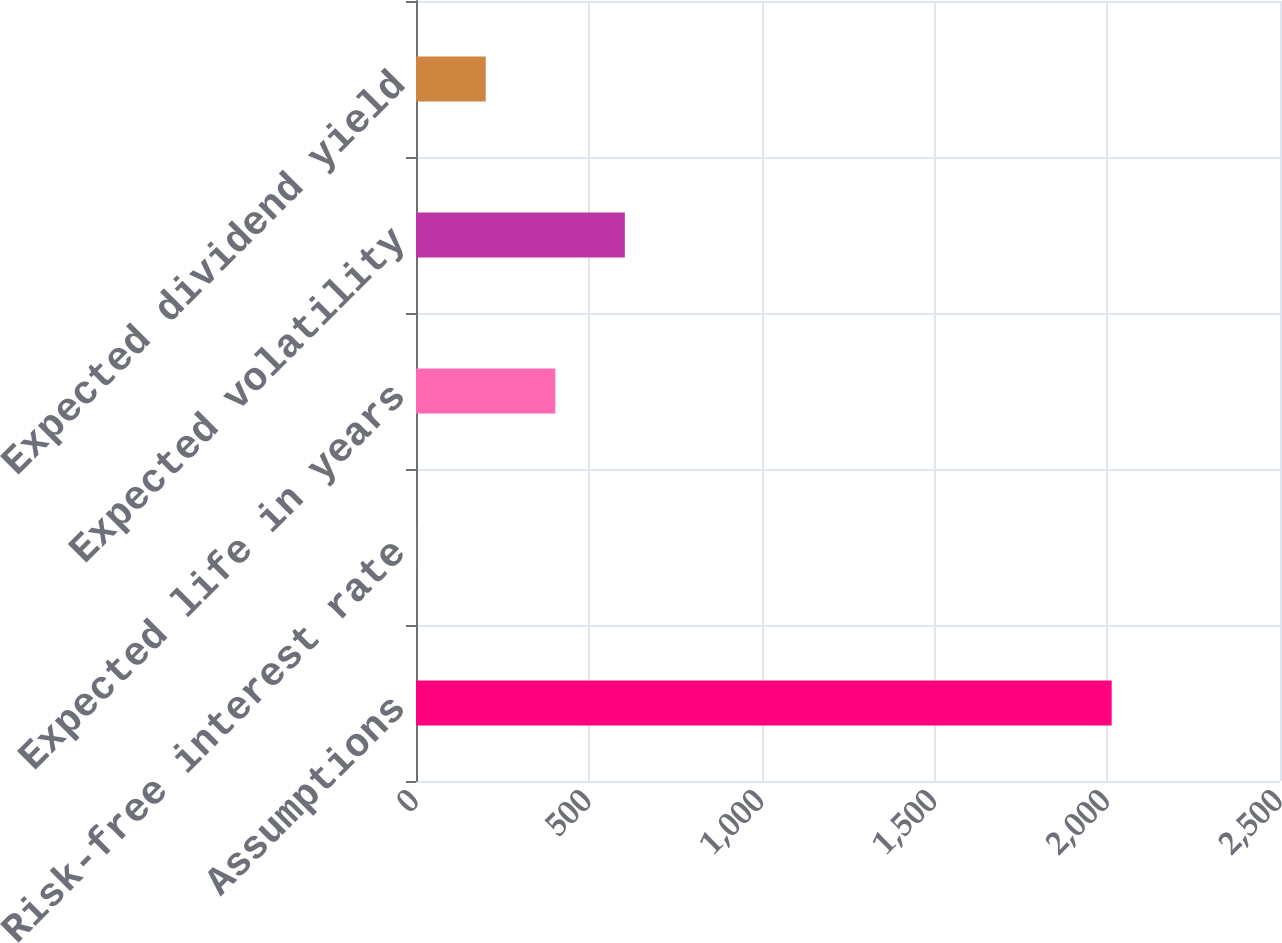<chart> <loc_0><loc_0><loc_500><loc_500><bar_chart><fcel>Assumptions<fcel>Risk-free interest rate<fcel>Expected life in years<fcel>Expected volatility<fcel>Expected dividend yield<nl><fcel>2013<fcel>0.53<fcel>403.03<fcel>604.28<fcel>201.78<nl></chart> 